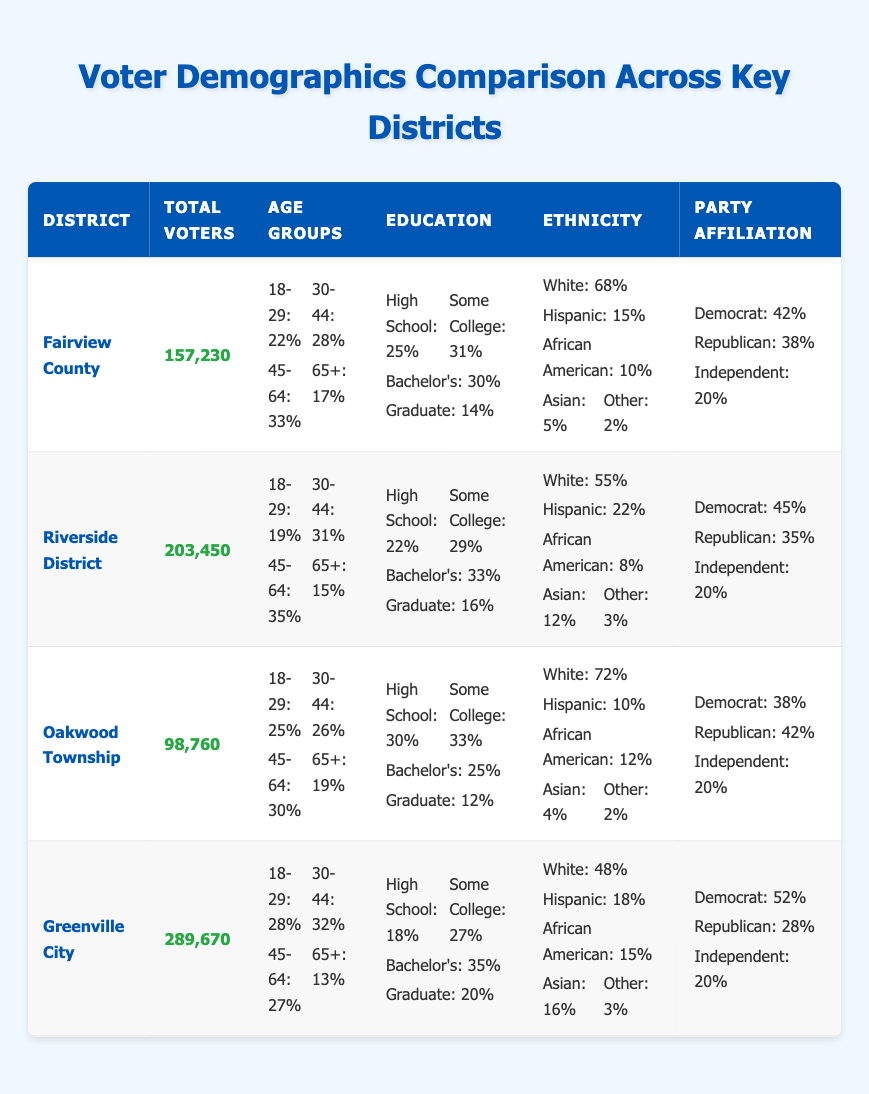What is the total number of voters in Oakwood Township? According to the data in the table, Oakwood Township has a value listed under "Total Voters," which is 98,760.
Answer: 98,760 Which district has the highest percentage of voters aged 65 or older? By comparing the age group percentages for 65+ across all districts, Fairview County has 17%, Riverside District has 15%, Oakwood Township has 19%, and Greenville City has 13%. The highest percentage is found in Oakwood Township.
Answer: Oakwood Township How many percent of voters in Greenville City hold a graduate degree? The table indicates that the percentage of voters with a graduate degree in Greenville City is 20%.
Answer: 20% What is the average percentage of Democrat party affiliation among all districts? To find the average, we sum the Democrat percentages: 42 (Fairview) + 45 (Riverside) + 38 (Oakwood) + 52 (Greenville) = 177. We divide by 4 (the number of districts), resulting in an average of 177/4 = 44.25%.
Answer: 44.25 Is the percentage of Hispanic voters higher in Riverside District compared to Fairview County? Riverside District has 22% of Hispanic voters, while Fairview County has 15%. Since 22% is greater than 15%, the statement is true.
Answer: Yes Which district has the lowest percentage of African American voters? By comparing the African American percentages, Fairview County has 10%, Riverside District has 8%, Oakwood Township has 12%, and Greenville City has 15%. The lowest percentage is in Riverside District, which has 8%.
Answer: Riverside District What is the difference in total voters between Greenville City and Fairview County? The total voters for Greenville City is 289,670, and for Fairview County, it is 157,230. The difference is calculated as 289,670 - 157,230 = 132,440.
Answer: 132,440 Which district has more total voters: Riverside District or Oakwood Township? Riverside District has 203,450 total voters and Oakwood Township has 98,760. Since 203,450 is greater than 98,760, Riverside District has more voters.
Answer: Riverside District What is the percentage of white voters in Oakwood Township? The table shows that in Oakwood Township, the percentage of white voters is 72%.
Answer: 72% 